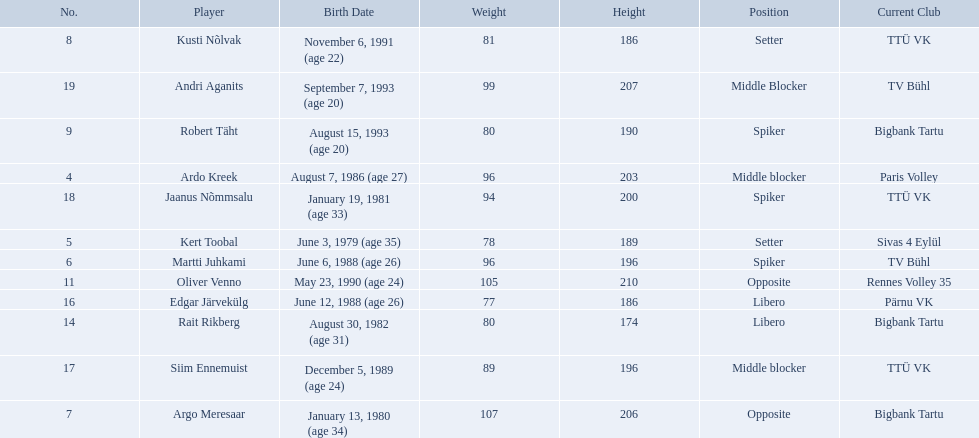Who are the players of the estonian men's national volleyball team? Ardo Kreek, Kert Toobal, Martti Juhkami, Argo Meresaar, Kusti Nõlvak, Robert Täht, Oliver Venno, Rait Rikberg, Edgar Järvekülg, Siim Ennemuist, Jaanus Nõmmsalu, Andri Aganits. Of these, which have a height over 200? Ardo Kreek, Argo Meresaar, Oliver Venno, Andri Aganits. Of the remaining, who is the tallest? Oliver Venno. What are the heights in cm of the men on the team? 203, 189, 196, 206, 186, 190, 210, 174, 186, 196, 200, 207. What is the tallest height of a team member? 210. Which player stands at 210? Oliver Venno. 